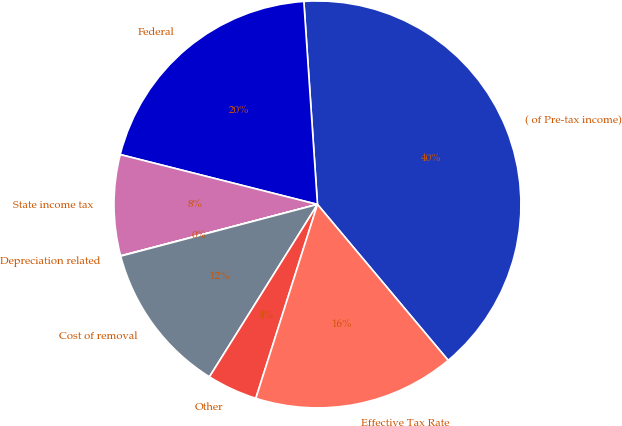Convert chart to OTSL. <chart><loc_0><loc_0><loc_500><loc_500><pie_chart><fcel>( of Pre-tax income)<fcel>Federal<fcel>State income tax<fcel>Depreciation related<fcel>Cost of removal<fcel>Other<fcel>Effective Tax Rate<nl><fcel>39.96%<fcel>19.99%<fcel>8.01%<fcel>0.02%<fcel>12.0%<fcel>4.01%<fcel>16.0%<nl></chart> 